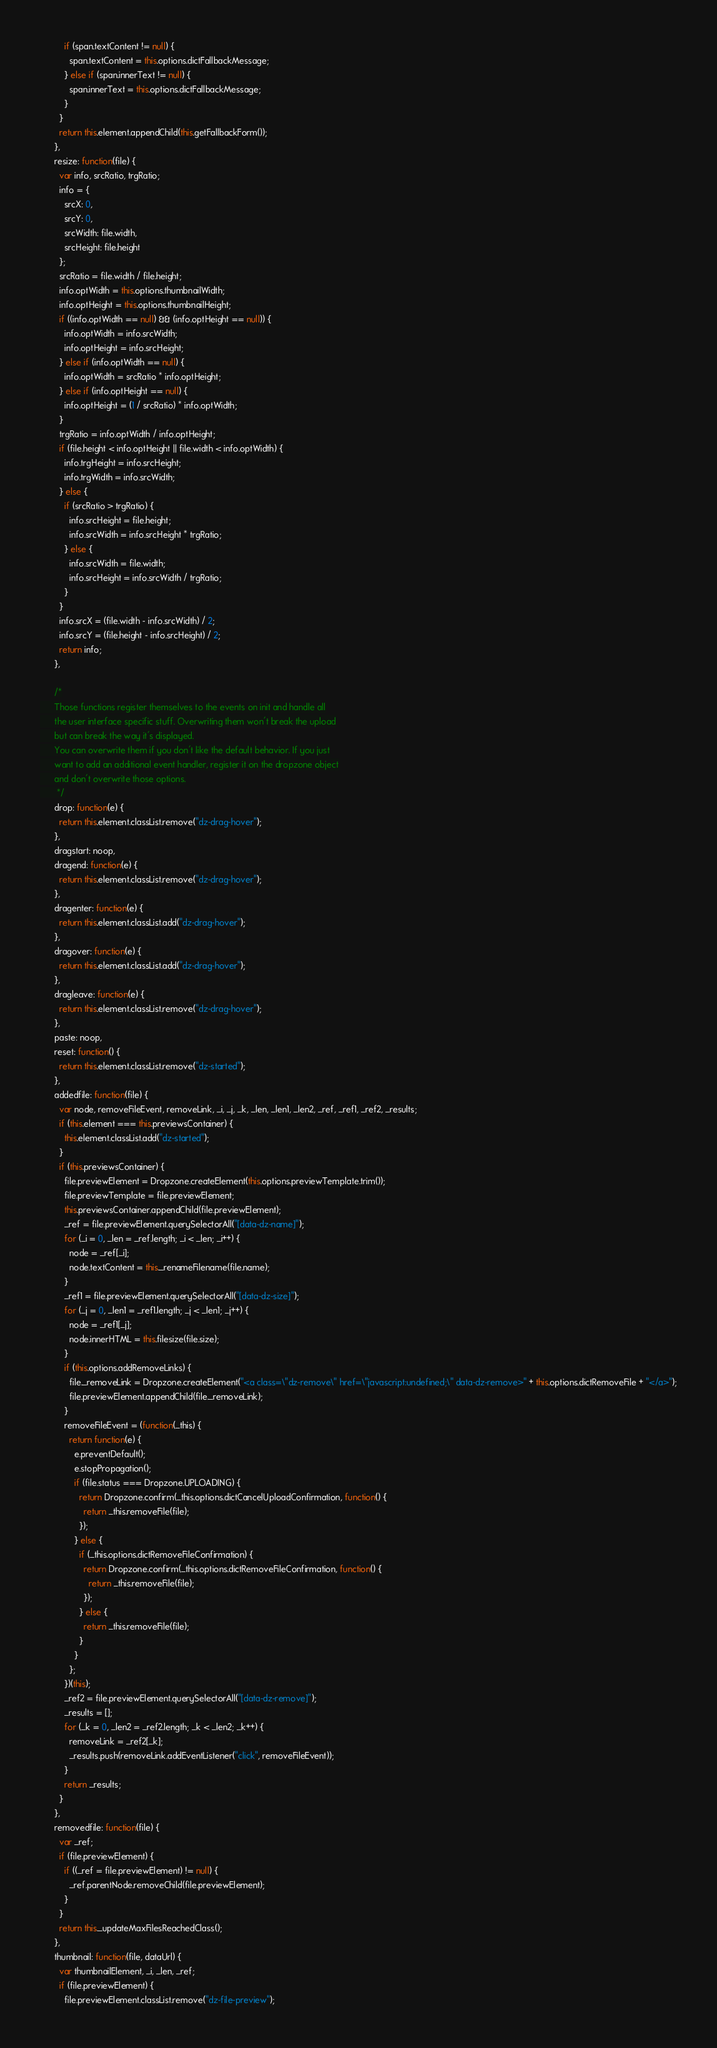<code> <loc_0><loc_0><loc_500><loc_500><_JavaScript_>          if (span.textContent != null) {
            span.textContent = this.options.dictFallbackMessage;
          } else if (span.innerText != null) {
            span.innerText = this.options.dictFallbackMessage;
          }
        }
        return this.element.appendChild(this.getFallbackForm());
      },
      resize: function(file) {
        var info, srcRatio, trgRatio;
        info = {
          srcX: 0,
          srcY: 0,
          srcWidth: file.width,
          srcHeight: file.height
        };
        srcRatio = file.width / file.height;
        info.optWidth = this.options.thumbnailWidth;
        info.optHeight = this.options.thumbnailHeight;
        if ((info.optWidth == null) && (info.optHeight == null)) {
          info.optWidth = info.srcWidth;
          info.optHeight = info.srcHeight;
        } else if (info.optWidth == null) {
          info.optWidth = srcRatio * info.optHeight;
        } else if (info.optHeight == null) {
          info.optHeight = (1 / srcRatio) * info.optWidth;
        }
        trgRatio = info.optWidth / info.optHeight;
        if (file.height < info.optHeight || file.width < info.optWidth) {
          info.trgHeight = info.srcHeight;
          info.trgWidth = info.srcWidth;
        } else {
          if (srcRatio > trgRatio) {
            info.srcHeight = file.height;
            info.srcWidth = info.srcHeight * trgRatio;
          } else {
            info.srcWidth = file.width;
            info.srcHeight = info.srcWidth / trgRatio;
          }
        }
        info.srcX = (file.width - info.srcWidth) / 2;
        info.srcY = (file.height - info.srcHeight) / 2;
        return info;
      },

      /*
      Those functions register themselves to the events on init and handle all
      the user interface specific stuff. Overwriting them won't break the upload
      but can break the way it's displayed.
      You can overwrite them if you don't like the default behavior. If you just
      want to add an additional event handler, register it on the dropzone object
      and don't overwrite those options.
       */
      drop: function(e) {
        return this.element.classList.remove("dz-drag-hover");
      },
      dragstart: noop,
      dragend: function(e) {
        return this.element.classList.remove("dz-drag-hover");
      },
      dragenter: function(e) {
        return this.element.classList.add("dz-drag-hover");
      },
      dragover: function(e) {
        return this.element.classList.add("dz-drag-hover");
      },
      dragleave: function(e) {
        return this.element.classList.remove("dz-drag-hover");
      },
      paste: noop,
      reset: function() {
        return this.element.classList.remove("dz-started");
      },
      addedfile: function(file) {
        var node, removeFileEvent, removeLink, _i, _j, _k, _len, _len1, _len2, _ref, _ref1, _ref2, _results;
        if (this.element === this.previewsContainer) {
          this.element.classList.add("dz-started");
        }
        if (this.previewsContainer) {
          file.previewElement = Dropzone.createElement(this.options.previewTemplate.trim());
          file.previewTemplate = file.previewElement;
          this.previewsContainer.appendChild(file.previewElement);
          _ref = file.previewElement.querySelectorAll("[data-dz-name]");
          for (_i = 0, _len = _ref.length; _i < _len; _i++) {
            node = _ref[_i];
            node.textContent = this._renameFilename(file.name);
          }
          _ref1 = file.previewElement.querySelectorAll("[data-dz-size]");
          for (_j = 0, _len1 = _ref1.length; _j < _len1; _j++) {
            node = _ref1[_j];
            node.innerHTML = this.filesize(file.size);
          }
          if (this.options.addRemoveLinks) {
            file._removeLink = Dropzone.createElement("<a class=\"dz-remove\" href=\"javascript:undefined;\" data-dz-remove>" + this.options.dictRemoveFile + "</a>");
            file.previewElement.appendChild(file._removeLink);
          }
          removeFileEvent = (function(_this) {
            return function(e) {
              e.preventDefault();
              e.stopPropagation();
              if (file.status === Dropzone.UPLOADING) {
                return Dropzone.confirm(_this.options.dictCancelUploadConfirmation, function() {
                  return _this.removeFile(file);
                });
              } else {
                if (_this.options.dictRemoveFileConfirmation) {
                  return Dropzone.confirm(_this.options.dictRemoveFileConfirmation, function() {
                    return _this.removeFile(file);
                  });
                } else {
                  return _this.removeFile(file);
                }
              }
            };
          })(this);
          _ref2 = file.previewElement.querySelectorAll("[data-dz-remove]");
          _results = [];
          for (_k = 0, _len2 = _ref2.length; _k < _len2; _k++) {
            removeLink = _ref2[_k];
            _results.push(removeLink.addEventListener("click", removeFileEvent));
          }
          return _results;
        }
      },
      removedfile: function(file) {
        var _ref;
        if (file.previewElement) {
          if ((_ref = file.previewElement) != null) {
            _ref.parentNode.removeChild(file.previewElement);
          }
        }
        return this._updateMaxFilesReachedClass();
      },
      thumbnail: function(file, dataUrl) {
        var thumbnailElement, _i, _len, _ref;
        if (file.previewElement) {
          file.previewElement.classList.remove("dz-file-preview");</code> 